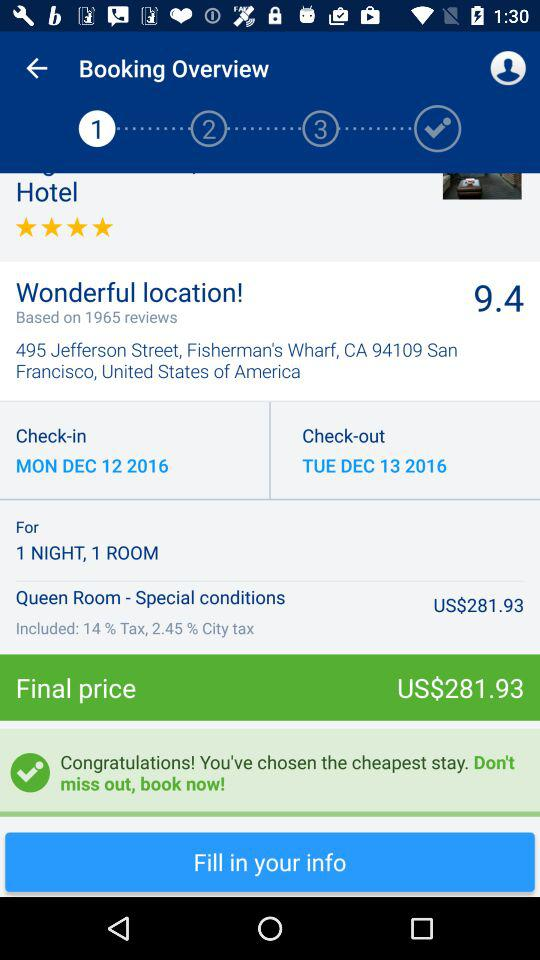What is the final price? The final price is US$281.93. 